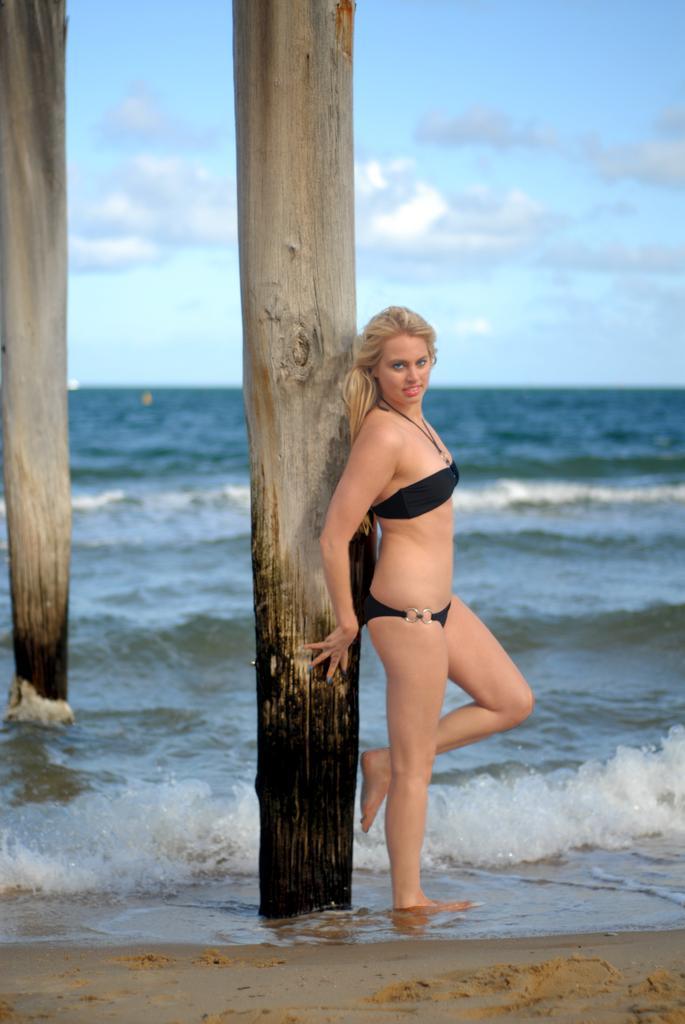Could you give a brief overview of what you see in this image? In the center of the image we can see poles and one person standing and she is smiling, which we can see on her face. In the background we can see the sky, clouds and water. 